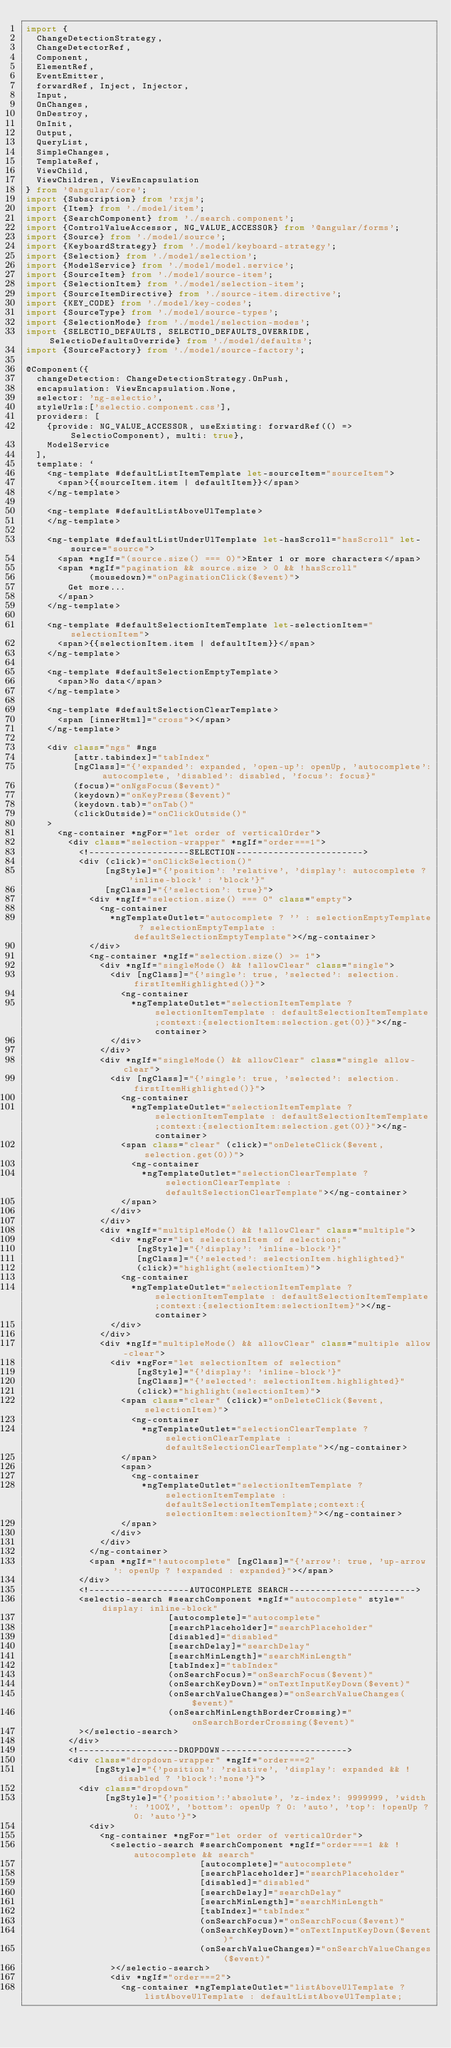<code> <loc_0><loc_0><loc_500><loc_500><_TypeScript_>import {
  ChangeDetectionStrategy,
  ChangeDetectorRef,
  Component,
  ElementRef,
  EventEmitter,
  forwardRef, Inject, Injector,
  Input,
  OnChanges,
  OnDestroy,
  OnInit,
  Output,
  QueryList,
  SimpleChanges,
  TemplateRef,
  ViewChild,
  ViewChildren, ViewEncapsulation
} from '@angular/core';
import {Subscription} from 'rxjs';
import {Item} from './model/item';
import {SearchComponent} from './search.component';
import {ControlValueAccessor, NG_VALUE_ACCESSOR} from '@angular/forms';
import {Source} from './model/source';
import {KeyboardStrategy} from './model/keyboard-strategy';
import {Selection} from './model/selection';
import {ModelService} from './model/model.service';
import {SourceItem} from './model/source-item';
import {SelectionItem} from './model/selection-item';
import {SourceItemDirective} from './source-item.directive';
import {KEY_CODE} from './model/key-codes';
import {SourceType} from './model/source-types';
import {SelectionMode} from './model/selection-modes';
import {SELECTIO_DEFAULTS, SELECTIO_DEFAULTS_OVERRIDE, SelectioDefaultsOverride} from './model/defaults';
import {SourceFactory} from './model/source-factory';

@Component({
  changeDetection: ChangeDetectionStrategy.OnPush,
  encapsulation: ViewEncapsulation.None,
  selector: 'ng-selectio',
  styleUrls:['selectio.component.css'],
  providers: [
    {provide: NG_VALUE_ACCESSOR, useExisting: forwardRef(() => SelectioComponent), multi: true},
    ModelService
  ],
  template: `
    <ng-template #defaultListItemTemplate let-sourceItem="sourceItem">
      <span>{{sourceItem.item | defaultItem}}</span>
    </ng-template>

    <ng-template #defaultListAboveUlTemplate>
    </ng-template>

    <ng-template #defaultListUnderUlTemplate let-hasScroll="hasScroll" let-source="source">
      <span *ngIf="(source.size() === 0)">Enter 1 or more characters</span>
      <span *ngIf="pagination && source.size > 0 && !hasScroll"
            (mousedown)="onPaginationClick($event)">
        Get more...
      </span>
    </ng-template>

    <ng-template #defaultSelectionItemTemplate let-selectionItem="selectionItem">
      <span>{{selectionItem.item | defaultItem}}</span>
    </ng-template>

    <ng-template #defaultSelectionEmptyTemplate>
      <span>No data</span>
    </ng-template>

    <ng-template #defaultSelectionClearTemplate>
      <span [innerHtml]="cross"></span>
    </ng-template>

    <div class="ngs" #ngs
         [attr.tabindex]="tabIndex"
         [ngClass]="{'expanded': expanded, 'open-up': openUp, 'autocomplete': autocomplete, 'disabled': disabled, 'focus': focus}"
         (focus)="onNgsFocus($event)"
         (keydown)="onKeyPress($event)"
         (keydown.tab)="onTab()"
         (clickOutside)="onClickOutside()"
    >
      <ng-container *ngFor="let order of verticalOrder">
        <div class="selection-wrapper" *ngIf="order===1">
          <!-------------------SELECTION------------------------>
          <div (click)="onClickSelection()"
               [ngStyle]="{'position': 'relative', 'display': autocomplete ? 'inline-block' : 'block'}"
               [ngClass]="{'selection': true}">
            <div *ngIf="selection.size() === 0" class="empty">
              <ng-container
                *ngTemplateOutlet="autocomplete ? '' : selectionEmptyTemplate ? selectionEmptyTemplate : defaultSelectionEmptyTemplate"></ng-container>
            </div>
            <ng-container *ngIf="selection.size() >= 1">
              <div *ngIf="singleMode() && !allowClear" class="single">
                <div [ngClass]="{'single': true, 'selected': selection.firstItemHighlighted()}">
                  <ng-container
                    *ngTemplateOutlet="selectionItemTemplate ? selectionItemTemplate : defaultSelectionItemTemplate;context:{selectionItem:selection.get(0)}"></ng-container>
                </div>
              </div>
              <div *ngIf="singleMode() && allowClear" class="single allow-clear">
                <div [ngClass]="{'single': true, 'selected': selection.firstItemHighlighted()}">
                  <ng-container
                    *ngTemplateOutlet="selectionItemTemplate ? selectionItemTemplate : defaultSelectionItemTemplate;context:{selectionItem:selection.get(0)}"></ng-container>
                  <span class="clear" (click)="onDeleteClick($event, selection.get(0))">
                    <ng-container
                      *ngTemplateOutlet="selectionClearTemplate ? selectionClearTemplate : defaultSelectionClearTemplate"></ng-container>
                  </span>
                </div>
              </div>
              <div *ngIf="multipleMode() && !allowClear" class="multiple">
                <div *ngFor="let selectionItem of selection;"
                     [ngStyle]="{'display': 'inline-block'}"
                     [ngClass]="{'selected': selectionItem.highlighted}"
                     (click)="highlight(selectionItem)">
                  <ng-container
                    *ngTemplateOutlet="selectionItemTemplate ? selectionItemTemplate : defaultSelectionItemTemplate;context:{selectionItem:selectionItem}"></ng-container>
                </div>
              </div>
              <div *ngIf="multipleMode() && allowClear" class="multiple allow-clear">
                <div *ngFor="let selectionItem of selection"
                     [ngStyle]="{'display': 'inline-block'}"
                     [ngClass]="{'selected': selectionItem.highlighted}"
                     (click)="highlight(selectionItem)">
                  <span class="clear" (click)="onDeleteClick($event, selectionItem)">
                    <ng-container
                      *ngTemplateOutlet="selectionClearTemplate ? selectionClearTemplate : defaultSelectionClearTemplate"></ng-container>
                  </span>
                  <span>
                    <ng-container
                      *ngTemplateOutlet="selectionItemTemplate ? selectionItemTemplate : defaultSelectionItemTemplate;context:{selectionItem:selectionItem}"></ng-container>
                  </span>
                </div>
              </div>
            </ng-container>
            <span *ngIf="!autocomplete" [ngClass]="{'arrow': true, 'up-arrow': openUp ? !expanded : expanded}"></span>
          </div>
          <!-------------------AUTOCOMPLETE SEARCH------------------------>
          <selectio-search #searchComponent *ngIf="autocomplete" style="display: inline-block"
                           [autocomplete]="autocomplete"
                           [searchPlaceholder]="searchPlaceholder"
                           [disabled]="disabled"
                           [searchDelay]="searchDelay"
                           [searchMinLength]="searchMinLength"
                           [tabIndex]="tabIndex"
                           (onSearchFocus)="onSearchFocus($event)"
                           (onSearchKeyDown)="onTextInputKeyDown($event)"
                           (onSearchValueChanges)="onSearchValueChanges($event)"
                           (onSearchMinLengthBorderCrossing)="onSearchBorderCrossing($event)"
          ></selectio-search>
        </div>
        <!-------------------DROPDOWN------------------------>
        <div class="dropdown-wrapper" *ngIf="order===2"
             [ngStyle]="{'position': 'relative', 'display': expanded && !disabled ? 'block':'none'}">
          <div class="dropdown"
               [ngStyle]="{'position':'absolute', 'z-index': 9999999, 'width': '100%', 'bottom': openUp ? 0: 'auto', 'top': !openUp ? 0: 'auto'}">
            <div>
              <ng-container *ngFor="let order of verticalOrder">
                <selectio-search #searchComponent *ngIf="order===1 && !autocomplete && search"
                                 [autocomplete]="autocomplete"
                                 [searchPlaceholder]="searchPlaceholder"
                                 [disabled]="disabled"
                                 [searchDelay]="searchDelay"
                                 [searchMinLength]="searchMinLength"
                                 [tabIndex]="tabIndex"
                                 (onSearchFocus)="onSearchFocus($event)"
                                 (onSearchKeyDown)="onTextInputKeyDown($event)"
                                 (onSearchValueChanges)="onSearchValueChanges($event)"
                ></selectio-search>
                <div *ngIf="order===2">
                  <ng-container *ngTemplateOutlet="listAboveUlTemplate ? listAboveUlTemplate : defaultListAboveUlTemplate;</code> 